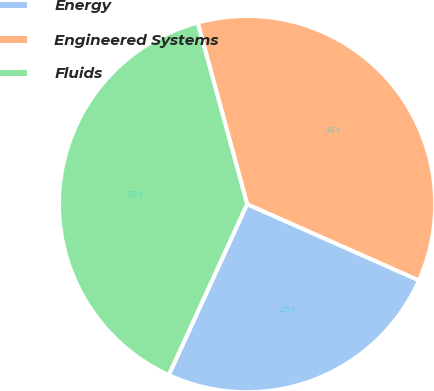<chart> <loc_0><loc_0><loc_500><loc_500><pie_chart><fcel>Energy<fcel>Engineered Systems<fcel>Fluids<nl><fcel>25.19%<fcel>35.88%<fcel>38.93%<nl></chart> 